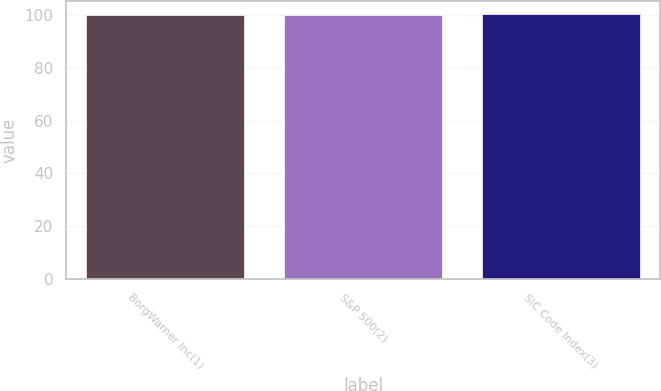<chart> <loc_0><loc_0><loc_500><loc_500><bar_chart><fcel>BorgWarner Inc(1)<fcel>S&P 500(2)<fcel>SIC Code Index(3)<nl><fcel>100<fcel>100.1<fcel>100.2<nl></chart> 